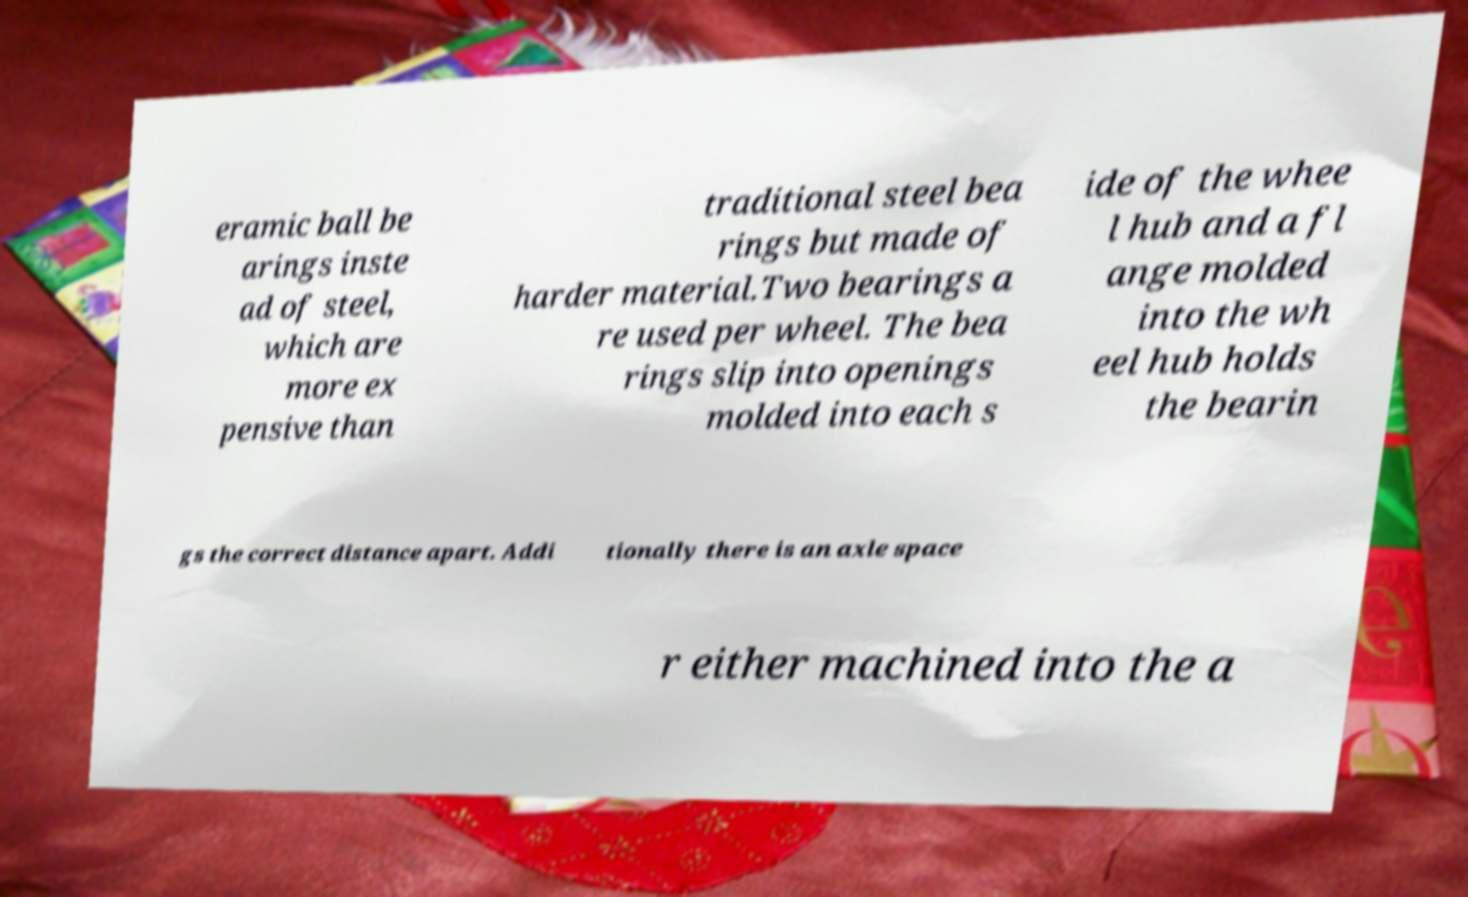Please read and relay the text visible in this image. What does it say? eramic ball be arings inste ad of steel, which are more ex pensive than traditional steel bea rings but made of harder material.Two bearings a re used per wheel. The bea rings slip into openings molded into each s ide of the whee l hub and a fl ange molded into the wh eel hub holds the bearin gs the correct distance apart. Addi tionally there is an axle space r either machined into the a 